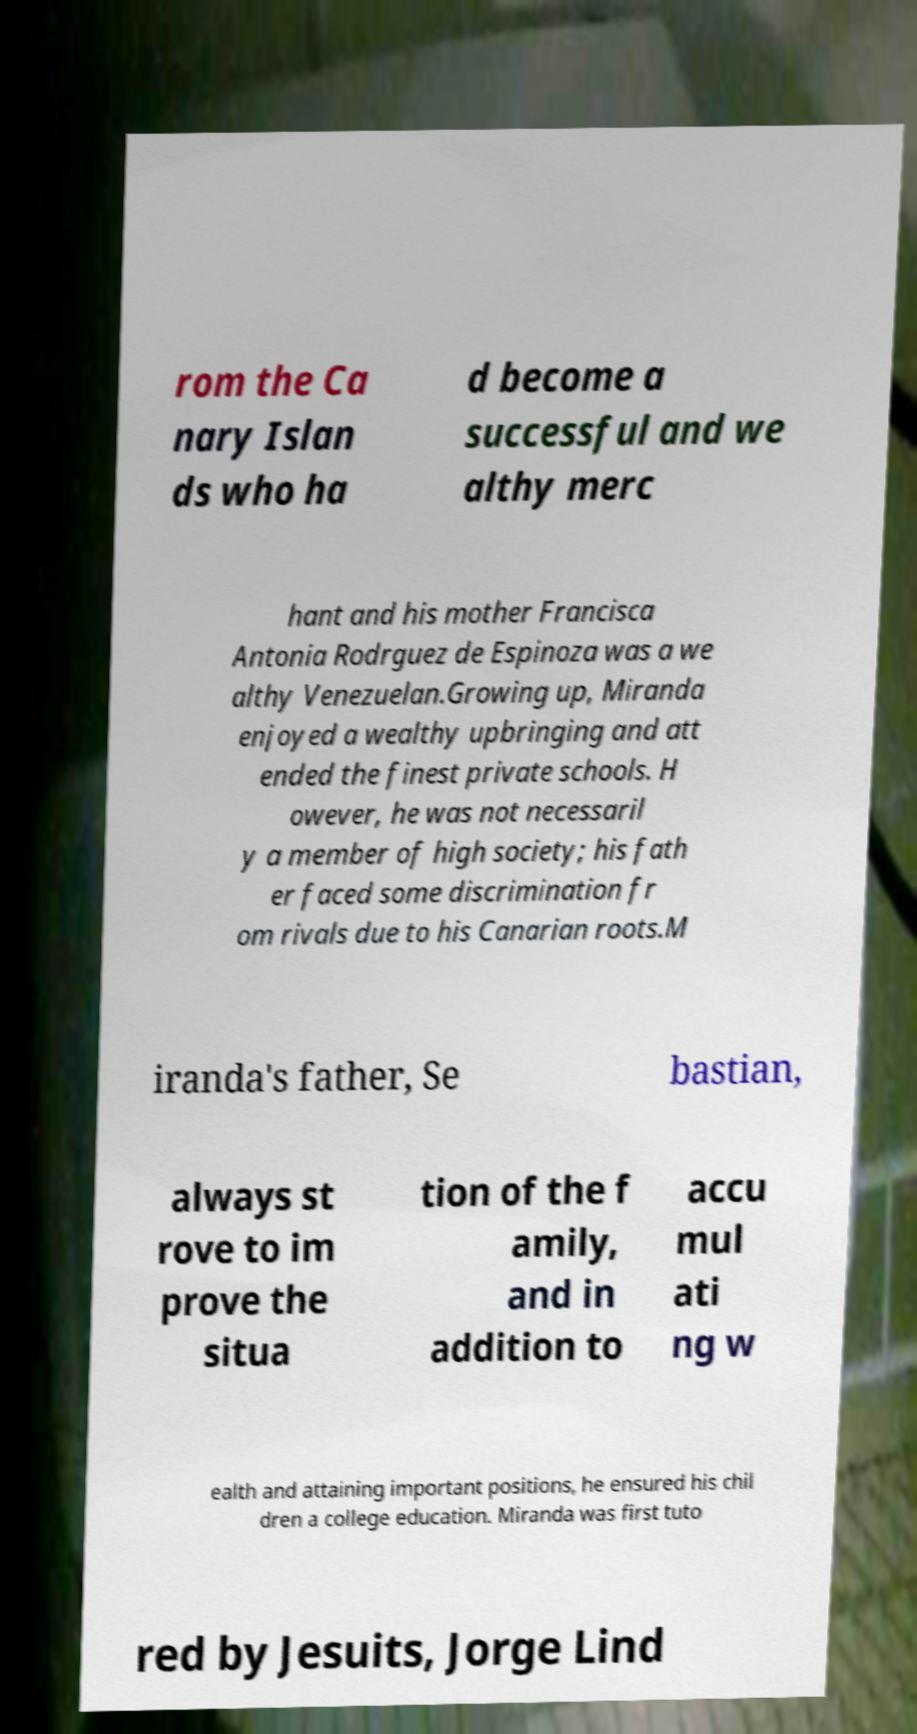Can you accurately transcribe the text from the provided image for me? rom the Ca nary Islan ds who ha d become a successful and we althy merc hant and his mother Francisca Antonia Rodrguez de Espinoza was a we althy Venezuelan.Growing up, Miranda enjoyed a wealthy upbringing and att ended the finest private schools. H owever, he was not necessaril y a member of high society; his fath er faced some discrimination fr om rivals due to his Canarian roots.M iranda's father, Se bastian, always st rove to im prove the situa tion of the f amily, and in addition to accu mul ati ng w ealth and attaining important positions, he ensured his chil dren a college education. Miranda was first tuto red by Jesuits, Jorge Lind 